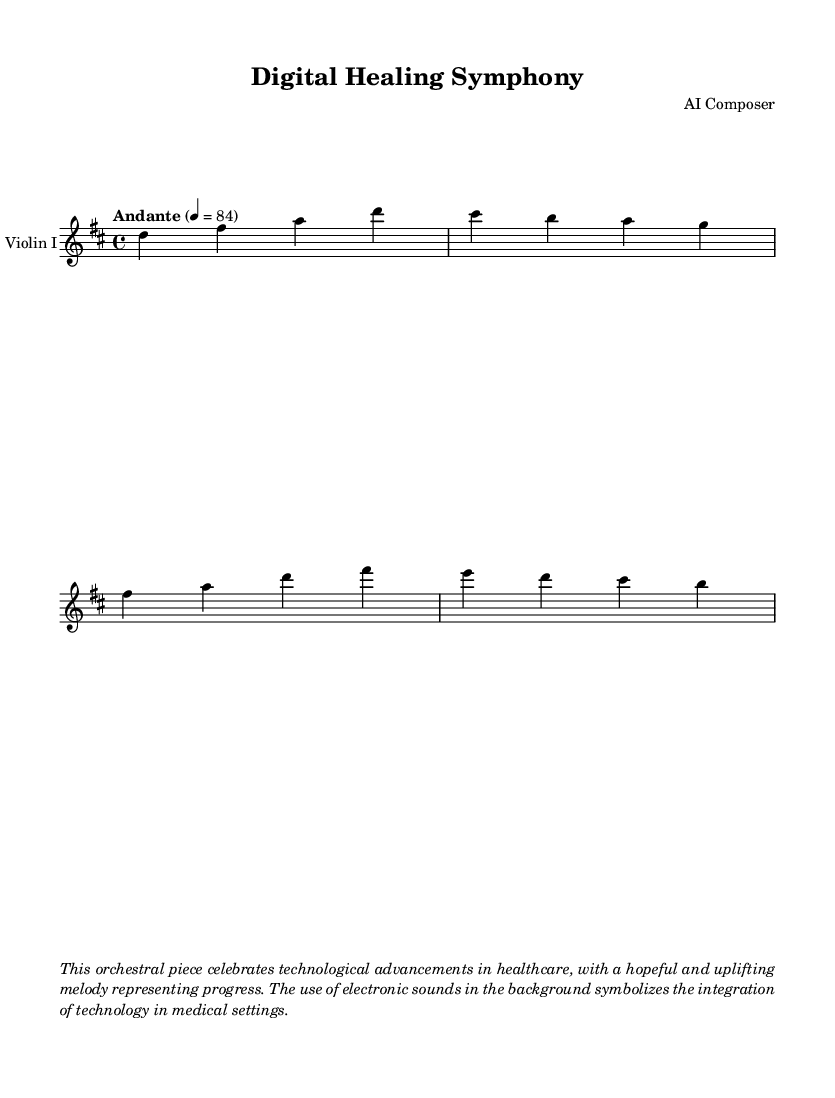What is the key signature of this music? The key signature is determined by the accidentals at the beginning of the staff. In this case, there are two sharps, indicating that the music is in D major.
Answer: D major What is the time signature of this music? The time signature is indicated by the numbers at the beginning of the staff. Here it shows 4 over 4, so there are four beats per measure.
Answer: 4/4 What is the tempo marking for this piece? The tempo marking is shown as "Andante," which is a term used to describe a moderate pace.
Answer: Andante How many measures are present in the excerpt? Counting the bar lines in the provided music, there are four measures, as indicated by the divisions in the staff.
Answer: 4 What does the melody signify in the context of the piece? The melody is uplifting and hopeful, which reflects themes of progress and integration of technology in healthcare.
Answer: Uplifting What instrument is this music composed for? The header and the staff label indicate that this piece is specifically written for "Violin I."
Answer: Violin I How does technology relate to the music piece? The score's description highlights that electronic sounds in the background symbolize technological integration in medical settings, enhancing the healthcare theme.
Answer: Technological integration 